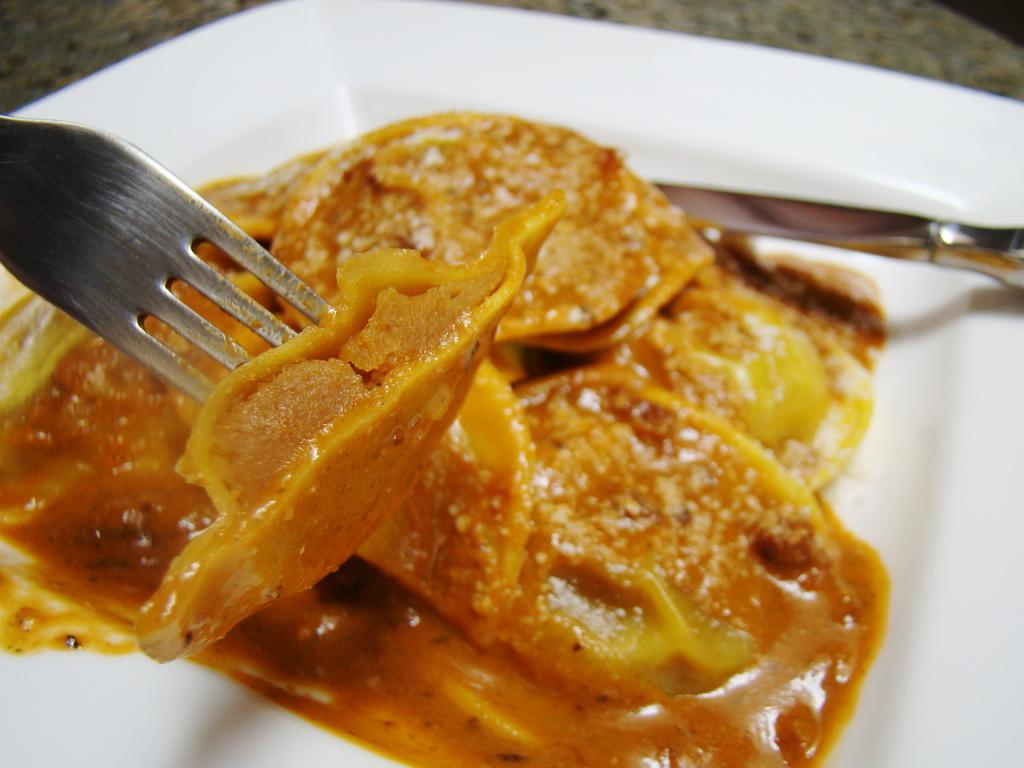What is the main object in the center of the image? There is a white color palette in the center of the image. What is on the palette? The palette contains food items. What utensil can be seen in the image? There is a fork visible in the image. What else is present on the palette besides the food items and fork? There are other items present on the palette. How does the goose interact with the loaf on the palette in the image? There is no goose or loaf present in the image; it features a white color palette with food items and a fork. What type of answer can be seen written on the palette in the image? There is no answer written on the palette in the image; it contains food items and other items. 